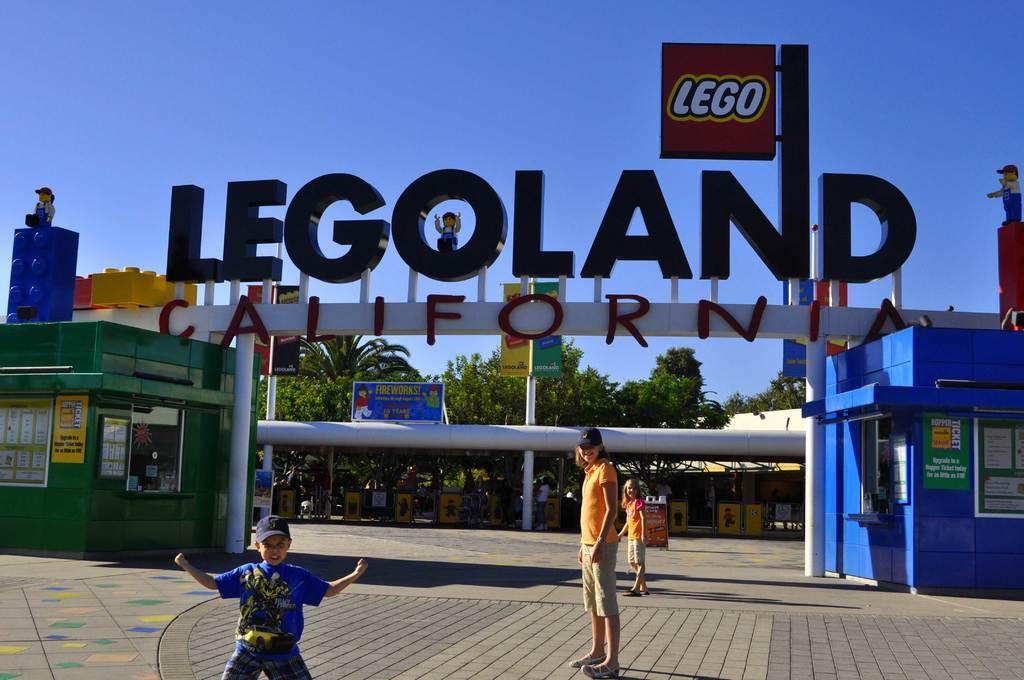How would you summarize this image in a sentence or two? In this picture I can see there is a person standing here and there are two kids here standing here and in the backdrop there is a arch and there is a name board here and in the backdrop I can see there are trees and the sky is clear. 